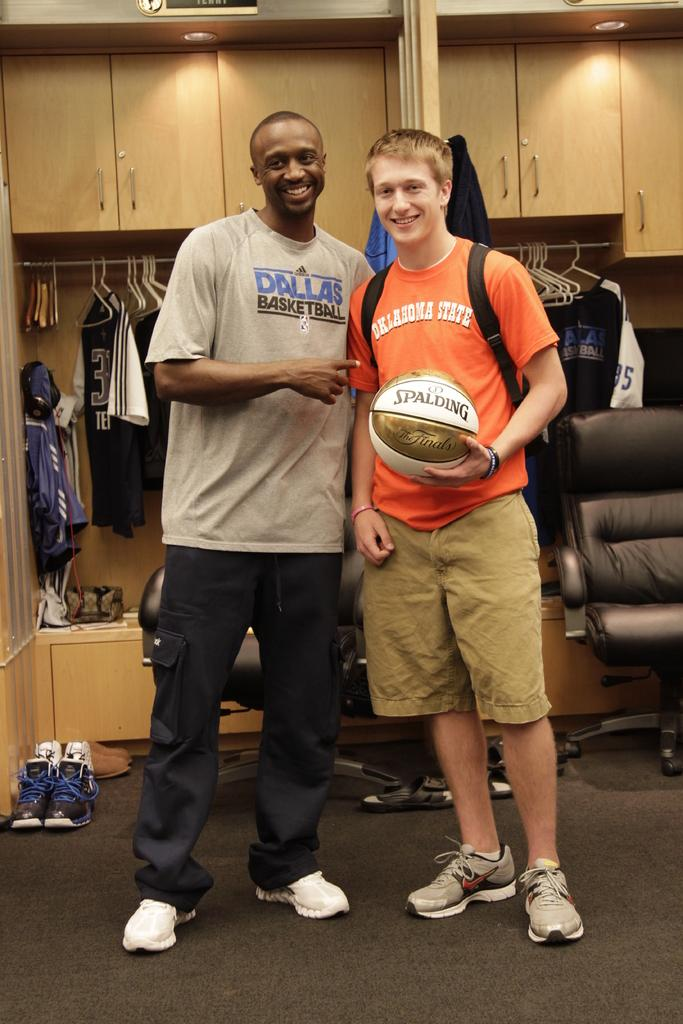<image>
Relay a brief, clear account of the picture shown. Two men, one wearing a Dallas basketball T-shirt, the other wearing an Oklahoma State T-shirt and holding a Spalding basket ball, are standing together. 